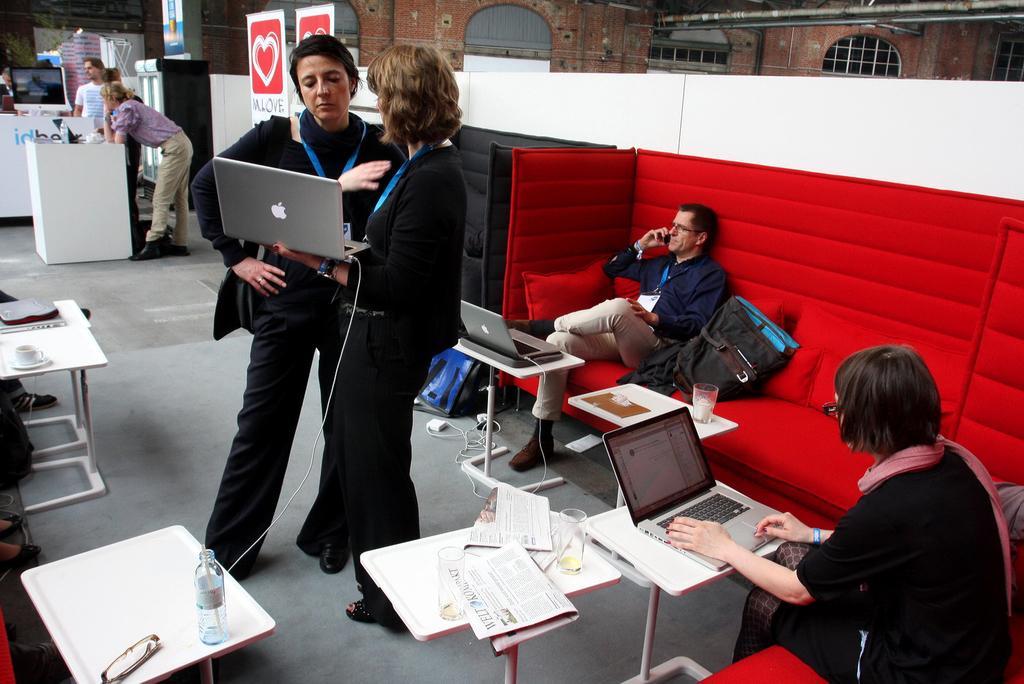Please provide a concise description of this image. This picture shows few people standing and a woman holding a laptop in her hand and we see two people seated and laptops on the table 